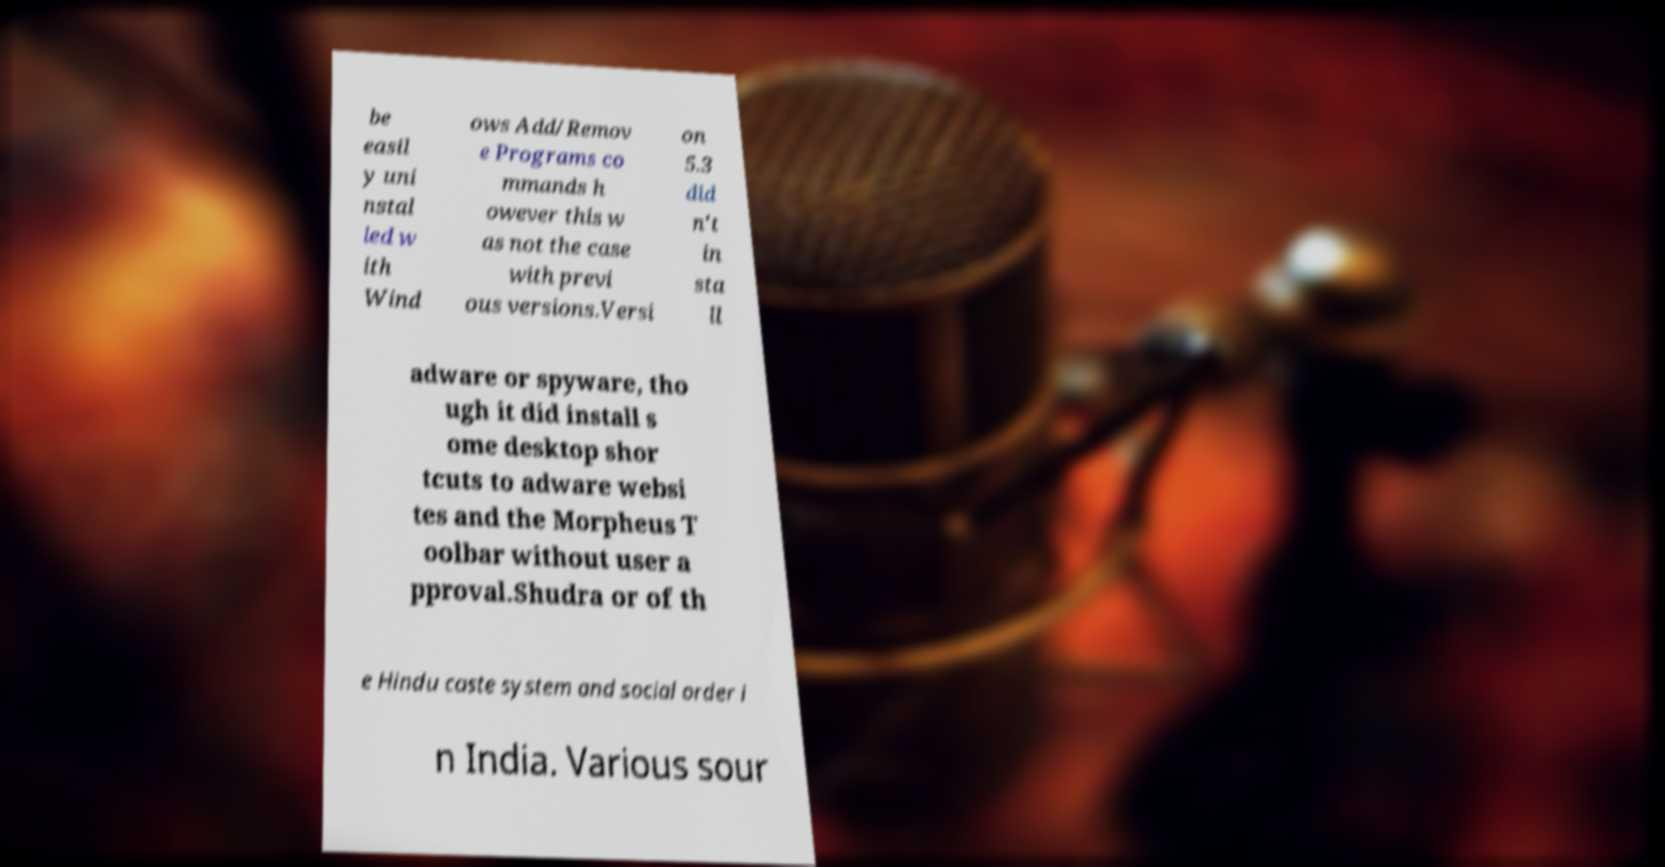Could you assist in decoding the text presented in this image and type it out clearly? be easil y uni nstal led w ith Wind ows Add/Remov e Programs co mmands h owever this w as not the case with previ ous versions.Versi on 5.3 did n't in sta ll adware or spyware, tho ugh it did install s ome desktop shor tcuts to adware websi tes and the Morpheus T oolbar without user a pproval.Shudra or of th e Hindu caste system and social order i n India. Various sour 